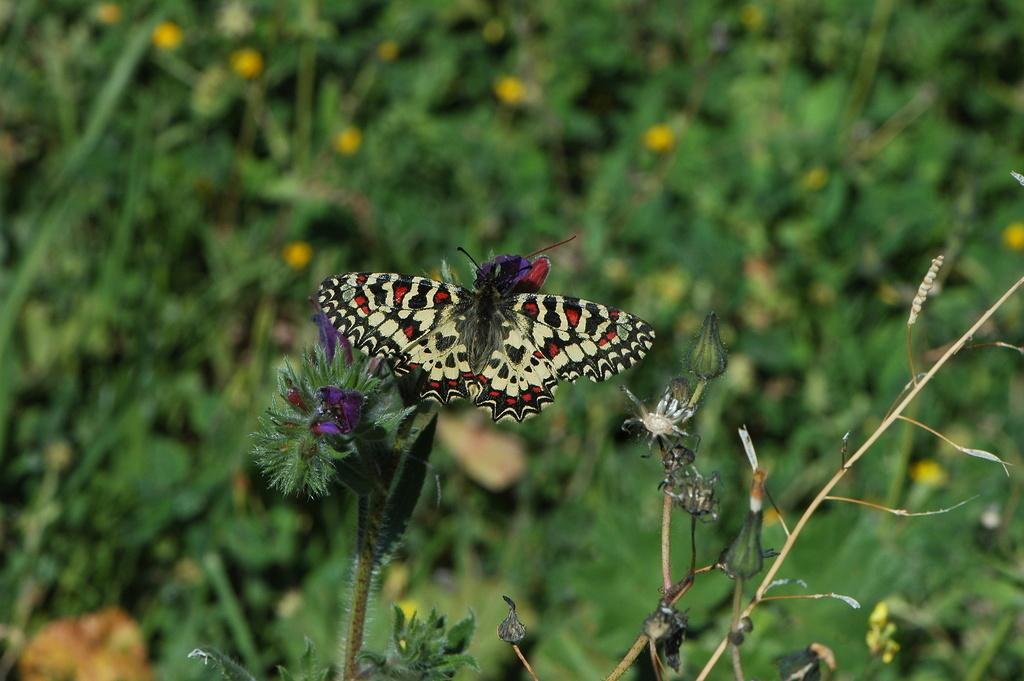What type of animal can be seen in the image? There is a butterfly in the image. What other creatures are present in the image? There are insects in the image. Where are the insects located? The insects are on plants. Can you describe the background of the image? The background of the image is blurred. What type of rhythm does the butterfly have in the image? The butterfly does not have a rhythm in the image; it is a still image. Can you tell me about the parent of the butterfly in the image? There is no information about the butterfly's parent in the image. 